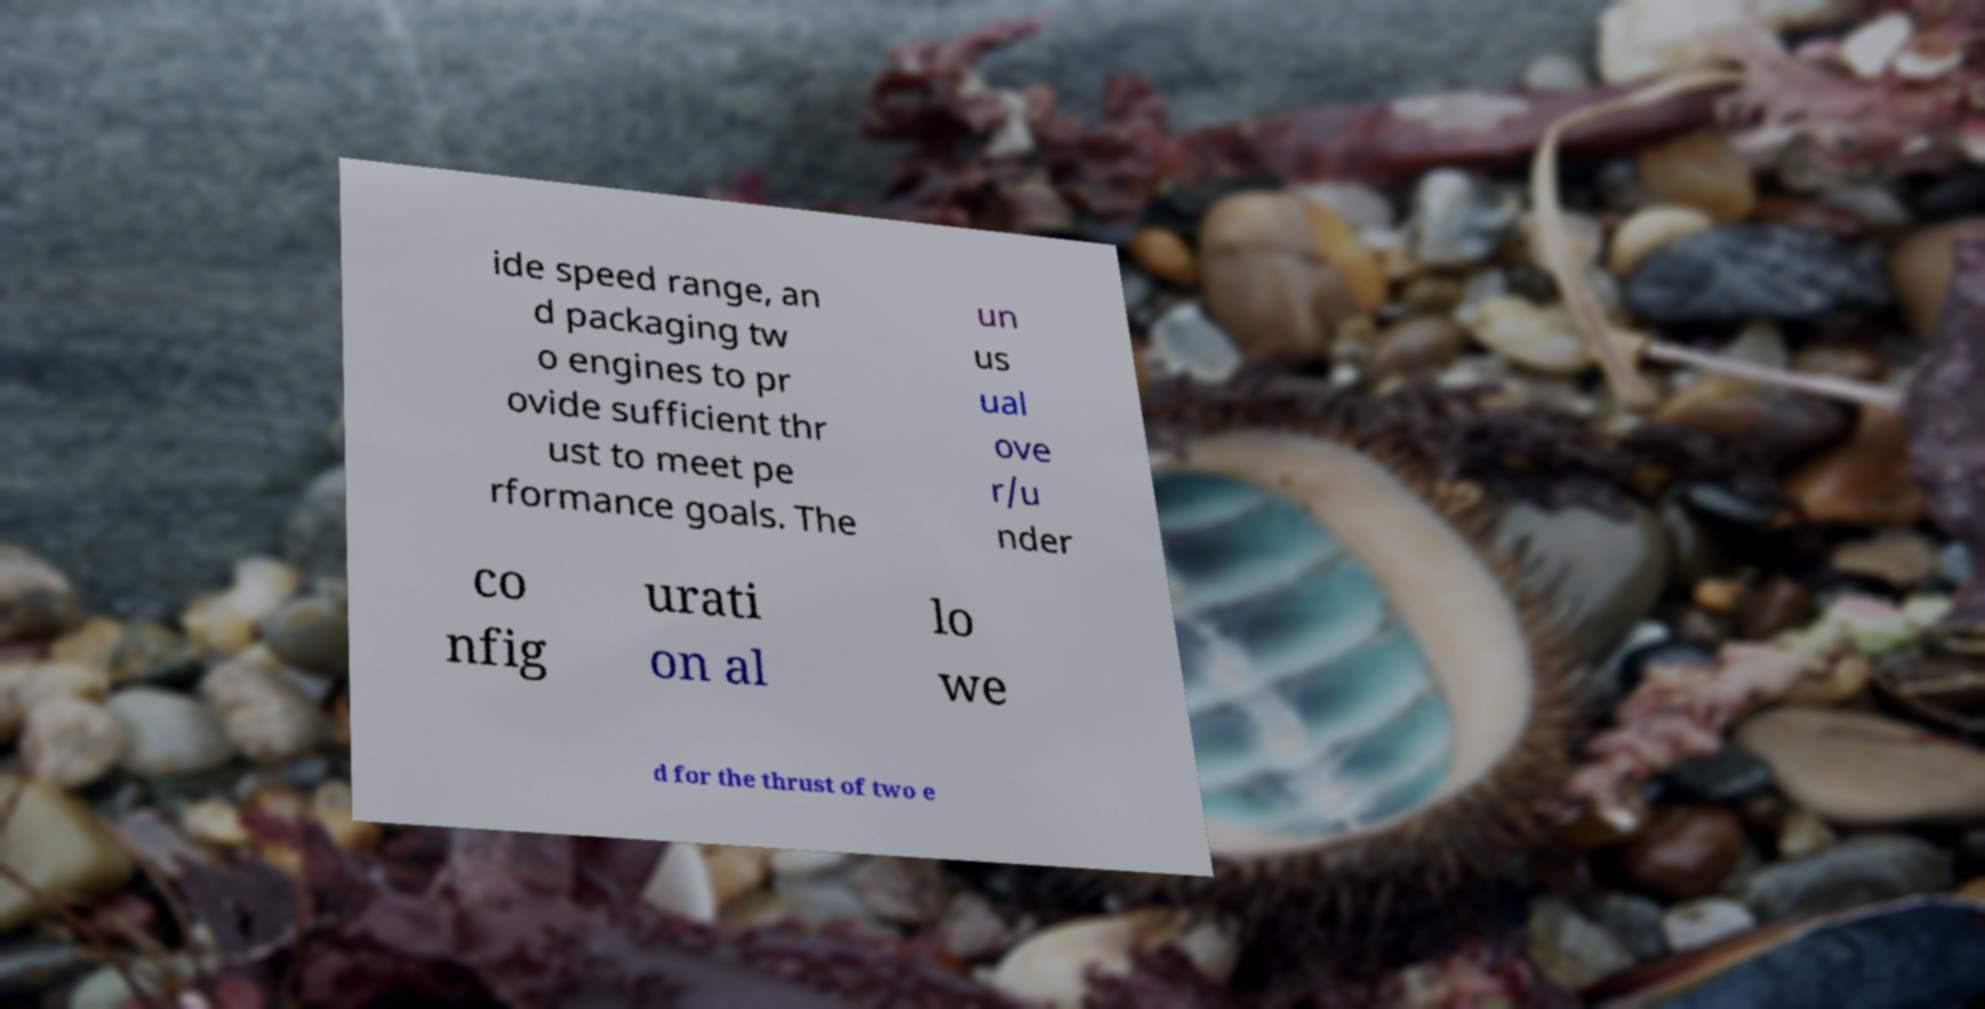There's text embedded in this image that I need extracted. Can you transcribe it verbatim? ide speed range, an d packaging tw o engines to pr ovide sufficient thr ust to meet pe rformance goals. The un us ual ove r/u nder co nfig urati on al lo we d for the thrust of two e 